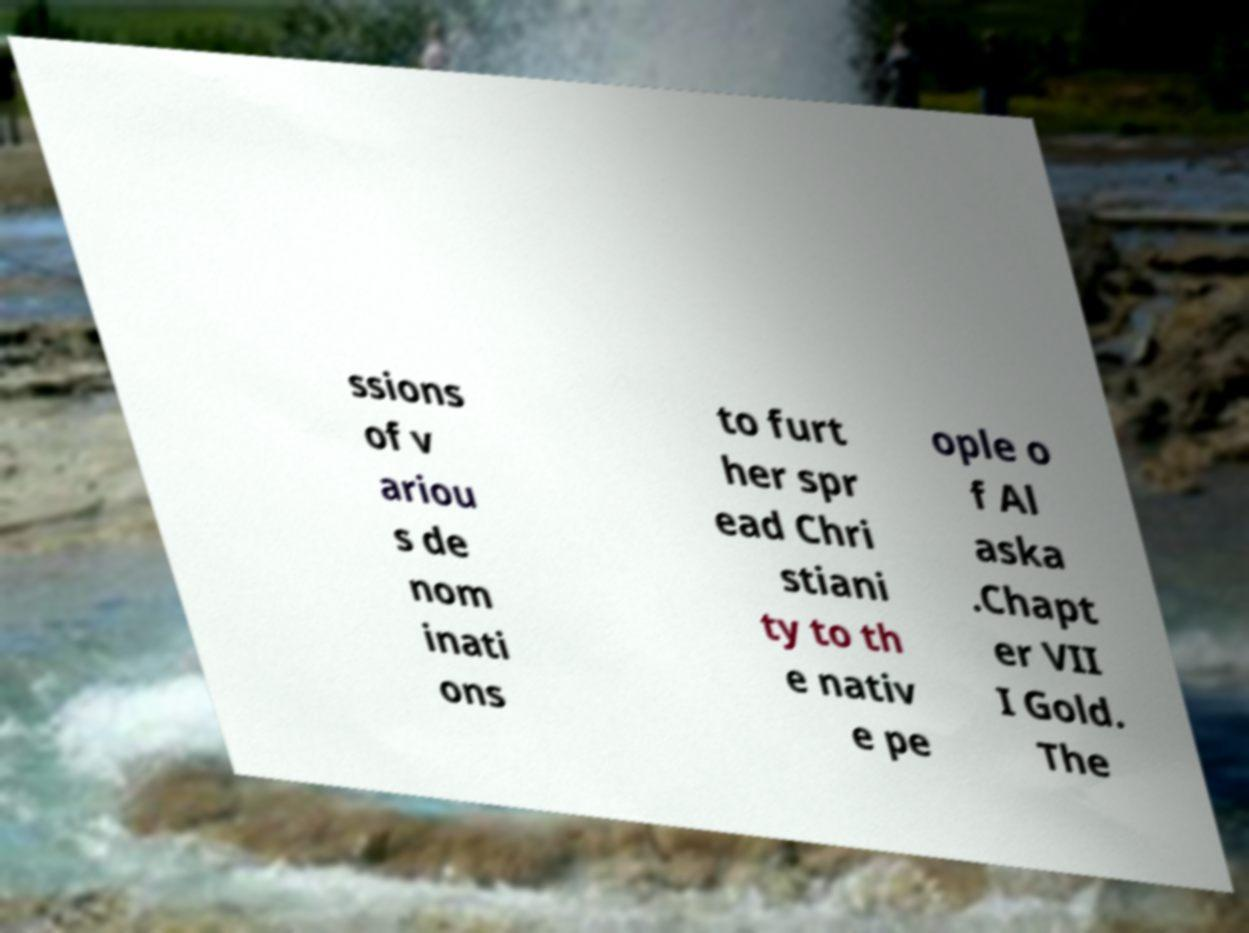I need the written content from this picture converted into text. Can you do that? ssions of v ariou s de nom inati ons to furt her spr ead Chri stiani ty to th e nativ e pe ople o f Al aska .Chapt er VII I Gold. The 